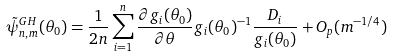Convert formula to latex. <formula><loc_0><loc_0><loc_500><loc_500>\tilde { \psi } _ { n , m } ^ { G H } ( \theta _ { 0 } ) = \frac { 1 } { 2 n } \sum _ { i = 1 } ^ { n } \frac { \partial g _ { i } ( \theta _ { 0 } ) } { \partial \theta } g _ { i } ( \theta _ { 0 } ) ^ { - 1 } \frac { D _ { i } } { g _ { i } ( \theta _ { 0 } ) } + O _ { p } ( m ^ { - 1 / 4 } )</formula> 